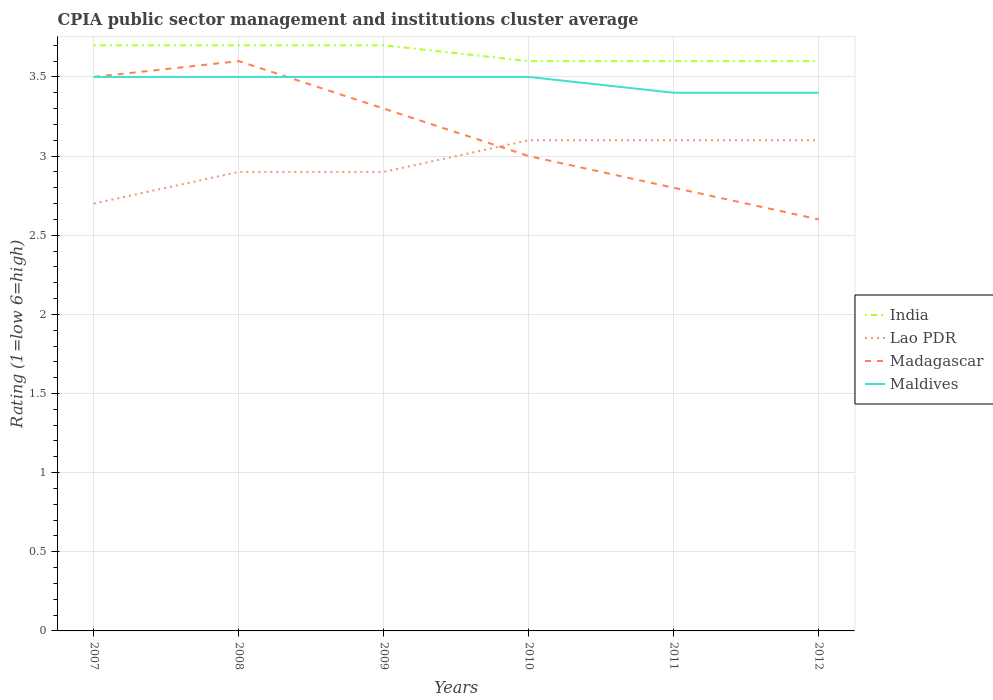Is the number of lines equal to the number of legend labels?
Provide a succinct answer. Yes. In which year was the CPIA rating in India maximum?
Keep it short and to the point. 2010. What is the total CPIA rating in Madagascar in the graph?
Your answer should be very brief. 0.2. What is the difference between the highest and the second highest CPIA rating in Lao PDR?
Give a very brief answer. 0.4. What is the difference between the highest and the lowest CPIA rating in Lao PDR?
Your answer should be very brief. 3. Is the CPIA rating in India strictly greater than the CPIA rating in Madagascar over the years?
Offer a terse response. No. How many years are there in the graph?
Keep it short and to the point. 6. What is the difference between two consecutive major ticks on the Y-axis?
Provide a short and direct response. 0.5. Does the graph contain any zero values?
Provide a succinct answer. No. What is the title of the graph?
Your response must be concise. CPIA public sector management and institutions cluster average. Does "Peru" appear as one of the legend labels in the graph?
Make the answer very short. No. What is the label or title of the Y-axis?
Provide a short and direct response. Rating (1=low 6=high). What is the Rating (1=low 6=high) in India in 2007?
Provide a short and direct response. 3.7. What is the Rating (1=low 6=high) in Lao PDR in 2008?
Give a very brief answer. 2.9. What is the Rating (1=low 6=high) in India in 2009?
Your answer should be compact. 3.7. What is the Rating (1=low 6=high) of Madagascar in 2009?
Keep it short and to the point. 3.3. What is the Rating (1=low 6=high) in Lao PDR in 2010?
Keep it short and to the point. 3.1. What is the Rating (1=low 6=high) in India in 2011?
Provide a succinct answer. 3.6. What is the Rating (1=low 6=high) in Lao PDR in 2011?
Your response must be concise. 3.1. What is the Rating (1=low 6=high) of Madagascar in 2011?
Provide a succinct answer. 2.8. What is the Rating (1=low 6=high) of Lao PDR in 2012?
Give a very brief answer. 3.1. What is the Rating (1=low 6=high) of Madagascar in 2012?
Ensure brevity in your answer.  2.6. What is the Rating (1=low 6=high) in Maldives in 2012?
Ensure brevity in your answer.  3.4. Across all years, what is the maximum Rating (1=low 6=high) in India?
Offer a terse response. 3.7. Across all years, what is the maximum Rating (1=low 6=high) in Lao PDR?
Your answer should be compact. 3.1. Across all years, what is the minimum Rating (1=low 6=high) of Lao PDR?
Give a very brief answer. 2.7. Across all years, what is the minimum Rating (1=low 6=high) in Madagascar?
Give a very brief answer. 2.6. What is the total Rating (1=low 6=high) in India in the graph?
Offer a very short reply. 21.9. What is the total Rating (1=low 6=high) in Lao PDR in the graph?
Ensure brevity in your answer.  17.8. What is the total Rating (1=low 6=high) of Madagascar in the graph?
Ensure brevity in your answer.  18.8. What is the total Rating (1=low 6=high) in Maldives in the graph?
Ensure brevity in your answer.  20.8. What is the difference between the Rating (1=low 6=high) in India in 2007 and that in 2008?
Your answer should be very brief. 0. What is the difference between the Rating (1=low 6=high) of Lao PDR in 2007 and that in 2008?
Provide a short and direct response. -0.2. What is the difference between the Rating (1=low 6=high) in Maldives in 2007 and that in 2008?
Provide a succinct answer. 0. What is the difference between the Rating (1=low 6=high) in India in 2007 and that in 2009?
Provide a short and direct response. 0. What is the difference between the Rating (1=low 6=high) in Madagascar in 2007 and that in 2009?
Offer a very short reply. 0.2. What is the difference between the Rating (1=low 6=high) of Maldives in 2007 and that in 2009?
Your answer should be very brief. 0. What is the difference between the Rating (1=low 6=high) in Madagascar in 2007 and that in 2010?
Offer a terse response. 0.5. What is the difference between the Rating (1=low 6=high) of Maldives in 2007 and that in 2010?
Keep it short and to the point. 0. What is the difference between the Rating (1=low 6=high) in India in 2007 and that in 2011?
Offer a terse response. 0.1. What is the difference between the Rating (1=low 6=high) of Lao PDR in 2007 and that in 2011?
Make the answer very short. -0.4. What is the difference between the Rating (1=low 6=high) of Madagascar in 2007 and that in 2011?
Keep it short and to the point. 0.7. What is the difference between the Rating (1=low 6=high) in India in 2007 and that in 2012?
Give a very brief answer. 0.1. What is the difference between the Rating (1=low 6=high) of Lao PDR in 2007 and that in 2012?
Your answer should be very brief. -0.4. What is the difference between the Rating (1=low 6=high) in Madagascar in 2007 and that in 2012?
Offer a very short reply. 0.9. What is the difference between the Rating (1=low 6=high) in Maldives in 2008 and that in 2009?
Provide a short and direct response. 0. What is the difference between the Rating (1=low 6=high) of India in 2008 and that in 2010?
Give a very brief answer. 0.1. What is the difference between the Rating (1=low 6=high) in Lao PDR in 2008 and that in 2010?
Ensure brevity in your answer.  -0.2. What is the difference between the Rating (1=low 6=high) of Madagascar in 2008 and that in 2011?
Offer a terse response. 0.8. What is the difference between the Rating (1=low 6=high) in Lao PDR in 2008 and that in 2012?
Make the answer very short. -0.2. What is the difference between the Rating (1=low 6=high) of Madagascar in 2008 and that in 2012?
Ensure brevity in your answer.  1. What is the difference between the Rating (1=low 6=high) of Maldives in 2008 and that in 2012?
Your response must be concise. 0.1. What is the difference between the Rating (1=low 6=high) of Lao PDR in 2009 and that in 2010?
Ensure brevity in your answer.  -0.2. What is the difference between the Rating (1=low 6=high) in Madagascar in 2009 and that in 2011?
Keep it short and to the point. 0.5. What is the difference between the Rating (1=low 6=high) of Maldives in 2009 and that in 2011?
Provide a short and direct response. 0.1. What is the difference between the Rating (1=low 6=high) in India in 2009 and that in 2012?
Ensure brevity in your answer.  0.1. What is the difference between the Rating (1=low 6=high) of Lao PDR in 2009 and that in 2012?
Make the answer very short. -0.2. What is the difference between the Rating (1=low 6=high) in Madagascar in 2009 and that in 2012?
Your answer should be compact. 0.7. What is the difference between the Rating (1=low 6=high) of India in 2010 and that in 2011?
Offer a terse response. 0. What is the difference between the Rating (1=low 6=high) of Lao PDR in 2010 and that in 2011?
Provide a short and direct response. 0. What is the difference between the Rating (1=low 6=high) in Madagascar in 2010 and that in 2011?
Offer a very short reply. 0.2. What is the difference between the Rating (1=low 6=high) of India in 2010 and that in 2012?
Provide a short and direct response. 0. What is the difference between the Rating (1=low 6=high) in Maldives in 2011 and that in 2012?
Provide a succinct answer. 0. What is the difference between the Rating (1=low 6=high) in India in 2007 and the Rating (1=low 6=high) in Lao PDR in 2008?
Make the answer very short. 0.8. What is the difference between the Rating (1=low 6=high) of Lao PDR in 2007 and the Rating (1=low 6=high) of Madagascar in 2008?
Offer a terse response. -0.9. What is the difference between the Rating (1=low 6=high) of Lao PDR in 2007 and the Rating (1=low 6=high) of Maldives in 2008?
Offer a very short reply. -0.8. What is the difference between the Rating (1=low 6=high) of India in 2007 and the Rating (1=low 6=high) of Lao PDR in 2009?
Give a very brief answer. 0.8. What is the difference between the Rating (1=low 6=high) in India in 2007 and the Rating (1=low 6=high) in Madagascar in 2009?
Offer a very short reply. 0.4. What is the difference between the Rating (1=low 6=high) in India in 2007 and the Rating (1=low 6=high) in Maldives in 2009?
Provide a short and direct response. 0.2. What is the difference between the Rating (1=low 6=high) of Lao PDR in 2007 and the Rating (1=low 6=high) of Madagascar in 2009?
Your answer should be compact. -0.6. What is the difference between the Rating (1=low 6=high) in Lao PDR in 2007 and the Rating (1=low 6=high) in Maldives in 2009?
Offer a very short reply. -0.8. What is the difference between the Rating (1=low 6=high) of India in 2007 and the Rating (1=low 6=high) of Madagascar in 2010?
Keep it short and to the point. 0.7. What is the difference between the Rating (1=low 6=high) of Lao PDR in 2007 and the Rating (1=low 6=high) of Madagascar in 2010?
Keep it short and to the point. -0.3. What is the difference between the Rating (1=low 6=high) in India in 2007 and the Rating (1=low 6=high) in Lao PDR in 2011?
Give a very brief answer. 0.6. What is the difference between the Rating (1=low 6=high) of India in 2007 and the Rating (1=low 6=high) of Madagascar in 2011?
Offer a very short reply. 0.9. What is the difference between the Rating (1=low 6=high) of Madagascar in 2007 and the Rating (1=low 6=high) of Maldives in 2011?
Your response must be concise. 0.1. What is the difference between the Rating (1=low 6=high) in Lao PDR in 2007 and the Rating (1=low 6=high) in Maldives in 2012?
Keep it short and to the point. -0.7. What is the difference between the Rating (1=low 6=high) of India in 2008 and the Rating (1=low 6=high) of Lao PDR in 2009?
Ensure brevity in your answer.  0.8. What is the difference between the Rating (1=low 6=high) in India in 2008 and the Rating (1=low 6=high) in Maldives in 2009?
Your response must be concise. 0.2. What is the difference between the Rating (1=low 6=high) in Lao PDR in 2008 and the Rating (1=low 6=high) in Madagascar in 2009?
Keep it short and to the point. -0.4. What is the difference between the Rating (1=low 6=high) of Lao PDR in 2008 and the Rating (1=low 6=high) of Maldives in 2009?
Your response must be concise. -0.6. What is the difference between the Rating (1=low 6=high) of India in 2008 and the Rating (1=low 6=high) of Lao PDR in 2010?
Your response must be concise. 0.6. What is the difference between the Rating (1=low 6=high) in India in 2008 and the Rating (1=low 6=high) in Lao PDR in 2011?
Your response must be concise. 0.6. What is the difference between the Rating (1=low 6=high) in India in 2008 and the Rating (1=low 6=high) in Madagascar in 2011?
Keep it short and to the point. 0.9. What is the difference between the Rating (1=low 6=high) of Lao PDR in 2008 and the Rating (1=low 6=high) of Maldives in 2011?
Make the answer very short. -0.5. What is the difference between the Rating (1=low 6=high) in India in 2008 and the Rating (1=low 6=high) in Maldives in 2012?
Make the answer very short. 0.3. What is the difference between the Rating (1=low 6=high) in Lao PDR in 2008 and the Rating (1=low 6=high) in Madagascar in 2012?
Make the answer very short. 0.3. What is the difference between the Rating (1=low 6=high) of Madagascar in 2008 and the Rating (1=low 6=high) of Maldives in 2012?
Ensure brevity in your answer.  0.2. What is the difference between the Rating (1=low 6=high) in India in 2009 and the Rating (1=low 6=high) in Madagascar in 2010?
Give a very brief answer. 0.7. What is the difference between the Rating (1=low 6=high) in India in 2009 and the Rating (1=low 6=high) in Maldives in 2010?
Keep it short and to the point. 0.2. What is the difference between the Rating (1=low 6=high) of Lao PDR in 2009 and the Rating (1=low 6=high) of Madagascar in 2010?
Your response must be concise. -0.1. What is the difference between the Rating (1=low 6=high) in Lao PDR in 2009 and the Rating (1=low 6=high) in Maldives in 2010?
Give a very brief answer. -0.6. What is the difference between the Rating (1=low 6=high) of India in 2009 and the Rating (1=low 6=high) of Maldives in 2011?
Offer a terse response. 0.3. What is the difference between the Rating (1=low 6=high) in Lao PDR in 2009 and the Rating (1=low 6=high) in Madagascar in 2011?
Your answer should be very brief. 0.1. What is the difference between the Rating (1=low 6=high) in Madagascar in 2009 and the Rating (1=low 6=high) in Maldives in 2011?
Provide a succinct answer. -0.1. What is the difference between the Rating (1=low 6=high) in India in 2009 and the Rating (1=low 6=high) in Lao PDR in 2012?
Ensure brevity in your answer.  0.6. What is the difference between the Rating (1=low 6=high) in Lao PDR in 2009 and the Rating (1=low 6=high) in Maldives in 2012?
Offer a terse response. -0.5. What is the difference between the Rating (1=low 6=high) of Madagascar in 2009 and the Rating (1=low 6=high) of Maldives in 2012?
Provide a short and direct response. -0.1. What is the difference between the Rating (1=low 6=high) in India in 2010 and the Rating (1=low 6=high) in Lao PDR in 2011?
Make the answer very short. 0.5. What is the difference between the Rating (1=low 6=high) in India in 2010 and the Rating (1=low 6=high) in Madagascar in 2011?
Keep it short and to the point. 0.8. What is the difference between the Rating (1=low 6=high) in India in 2010 and the Rating (1=low 6=high) in Maldives in 2011?
Provide a succinct answer. 0.2. What is the difference between the Rating (1=low 6=high) of Lao PDR in 2010 and the Rating (1=low 6=high) of Maldives in 2011?
Keep it short and to the point. -0.3. What is the difference between the Rating (1=low 6=high) of India in 2010 and the Rating (1=low 6=high) of Madagascar in 2012?
Offer a terse response. 1. What is the difference between the Rating (1=low 6=high) in India in 2010 and the Rating (1=low 6=high) in Maldives in 2012?
Make the answer very short. 0.2. What is the difference between the Rating (1=low 6=high) in Lao PDR in 2010 and the Rating (1=low 6=high) in Madagascar in 2012?
Your answer should be very brief. 0.5. What is the difference between the Rating (1=low 6=high) in Madagascar in 2010 and the Rating (1=low 6=high) in Maldives in 2012?
Your answer should be very brief. -0.4. What is the difference between the Rating (1=low 6=high) in India in 2011 and the Rating (1=low 6=high) in Lao PDR in 2012?
Offer a terse response. 0.5. What is the difference between the Rating (1=low 6=high) in India in 2011 and the Rating (1=low 6=high) in Maldives in 2012?
Provide a succinct answer. 0.2. What is the difference between the Rating (1=low 6=high) of Lao PDR in 2011 and the Rating (1=low 6=high) of Madagascar in 2012?
Provide a short and direct response. 0.5. What is the difference between the Rating (1=low 6=high) in Lao PDR in 2011 and the Rating (1=low 6=high) in Maldives in 2012?
Offer a terse response. -0.3. What is the difference between the Rating (1=low 6=high) of Madagascar in 2011 and the Rating (1=low 6=high) of Maldives in 2012?
Your answer should be compact. -0.6. What is the average Rating (1=low 6=high) in India per year?
Your answer should be very brief. 3.65. What is the average Rating (1=low 6=high) of Lao PDR per year?
Your answer should be compact. 2.97. What is the average Rating (1=low 6=high) of Madagascar per year?
Make the answer very short. 3.13. What is the average Rating (1=low 6=high) in Maldives per year?
Provide a short and direct response. 3.47. In the year 2007, what is the difference between the Rating (1=low 6=high) of India and Rating (1=low 6=high) of Lao PDR?
Your response must be concise. 1. In the year 2007, what is the difference between the Rating (1=low 6=high) in Lao PDR and Rating (1=low 6=high) in Madagascar?
Keep it short and to the point. -0.8. In the year 2007, what is the difference between the Rating (1=low 6=high) in Lao PDR and Rating (1=low 6=high) in Maldives?
Provide a short and direct response. -0.8. In the year 2008, what is the difference between the Rating (1=low 6=high) in India and Rating (1=low 6=high) in Maldives?
Offer a terse response. 0.2. In the year 2008, what is the difference between the Rating (1=low 6=high) of Lao PDR and Rating (1=low 6=high) of Madagascar?
Give a very brief answer. -0.7. In the year 2008, what is the difference between the Rating (1=low 6=high) of Lao PDR and Rating (1=low 6=high) of Maldives?
Give a very brief answer. -0.6. In the year 2008, what is the difference between the Rating (1=low 6=high) in Madagascar and Rating (1=low 6=high) in Maldives?
Your answer should be compact. 0.1. In the year 2009, what is the difference between the Rating (1=low 6=high) in India and Rating (1=low 6=high) in Lao PDR?
Provide a short and direct response. 0.8. In the year 2009, what is the difference between the Rating (1=low 6=high) in India and Rating (1=low 6=high) in Madagascar?
Offer a terse response. 0.4. In the year 2009, what is the difference between the Rating (1=low 6=high) in India and Rating (1=low 6=high) in Maldives?
Provide a short and direct response. 0.2. In the year 2009, what is the difference between the Rating (1=low 6=high) in Lao PDR and Rating (1=low 6=high) in Madagascar?
Provide a succinct answer. -0.4. In the year 2010, what is the difference between the Rating (1=low 6=high) of India and Rating (1=low 6=high) of Maldives?
Your answer should be compact. 0.1. In the year 2010, what is the difference between the Rating (1=low 6=high) of Lao PDR and Rating (1=low 6=high) of Maldives?
Provide a short and direct response. -0.4. In the year 2011, what is the difference between the Rating (1=low 6=high) of India and Rating (1=low 6=high) of Lao PDR?
Provide a short and direct response. 0.5. In the year 2011, what is the difference between the Rating (1=low 6=high) in Lao PDR and Rating (1=low 6=high) in Maldives?
Your answer should be very brief. -0.3. In the year 2011, what is the difference between the Rating (1=low 6=high) in Madagascar and Rating (1=low 6=high) in Maldives?
Give a very brief answer. -0.6. In the year 2012, what is the difference between the Rating (1=low 6=high) in India and Rating (1=low 6=high) in Lao PDR?
Make the answer very short. 0.5. In the year 2012, what is the difference between the Rating (1=low 6=high) of Lao PDR and Rating (1=low 6=high) of Madagascar?
Your response must be concise. 0.5. In the year 2012, what is the difference between the Rating (1=low 6=high) of Madagascar and Rating (1=low 6=high) of Maldives?
Your answer should be very brief. -0.8. What is the ratio of the Rating (1=low 6=high) of Madagascar in 2007 to that in 2008?
Offer a very short reply. 0.97. What is the ratio of the Rating (1=low 6=high) in Maldives in 2007 to that in 2008?
Your answer should be compact. 1. What is the ratio of the Rating (1=low 6=high) in Lao PDR in 2007 to that in 2009?
Your answer should be compact. 0.93. What is the ratio of the Rating (1=low 6=high) of Madagascar in 2007 to that in 2009?
Provide a short and direct response. 1.06. What is the ratio of the Rating (1=low 6=high) in India in 2007 to that in 2010?
Make the answer very short. 1.03. What is the ratio of the Rating (1=low 6=high) of Lao PDR in 2007 to that in 2010?
Ensure brevity in your answer.  0.87. What is the ratio of the Rating (1=low 6=high) in India in 2007 to that in 2011?
Offer a very short reply. 1.03. What is the ratio of the Rating (1=low 6=high) in Lao PDR in 2007 to that in 2011?
Make the answer very short. 0.87. What is the ratio of the Rating (1=low 6=high) of Madagascar in 2007 to that in 2011?
Offer a terse response. 1.25. What is the ratio of the Rating (1=low 6=high) in Maldives in 2007 to that in 2011?
Offer a very short reply. 1.03. What is the ratio of the Rating (1=low 6=high) in India in 2007 to that in 2012?
Provide a short and direct response. 1.03. What is the ratio of the Rating (1=low 6=high) in Lao PDR in 2007 to that in 2012?
Make the answer very short. 0.87. What is the ratio of the Rating (1=low 6=high) in Madagascar in 2007 to that in 2012?
Ensure brevity in your answer.  1.35. What is the ratio of the Rating (1=low 6=high) of Maldives in 2007 to that in 2012?
Provide a succinct answer. 1.03. What is the ratio of the Rating (1=low 6=high) of Madagascar in 2008 to that in 2009?
Ensure brevity in your answer.  1.09. What is the ratio of the Rating (1=low 6=high) of India in 2008 to that in 2010?
Offer a very short reply. 1.03. What is the ratio of the Rating (1=low 6=high) of Lao PDR in 2008 to that in 2010?
Ensure brevity in your answer.  0.94. What is the ratio of the Rating (1=low 6=high) in Madagascar in 2008 to that in 2010?
Offer a terse response. 1.2. What is the ratio of the Rating (1=low 6=high) of India in 2008 to that in 2011?
Ensure brevity in your answer.  1.03. What is the ratio of the Rating (1=low 6=high) in Lao PDR in 2008 to that in 2011?
Your answer should be very brief. 0.94. What is the ratio of the Rating (1=low 6=high) in Madagascar in 2008 to that in 2011?
Give a very brief answer. 1.29. What is the ratio of the Rating (1=low 6=high) in Maldives in 2008 to that in 2011?
Provide a succinct answer. 1.03. What is the ratio of the Rating (1=low 6=high) of India in 2008 to that in 2012?
Provide a short and direct response. 1.03. What is the ratio of the Rating (1=low 6=high) of Lao PDR in 2008 to that in 2012?
Your answer should be compact. 0.94. What is the ratio of the Rating (1=low 6=high) of Madagascar in 2008 to that in 2012?
Your answer should be very brief. 1.38. What is the ratio of the Rating (1=low 6=high) in Maldives in 2008 to that in 2012?
Make the answer very short. 1.03. What is the ratio of the Rating (1=low 6=high) in India in 2009 to that in 2010?
Your answer should be compact. 1.03. What is the ratio of the Rating (1=low 6=high) in Lao PDR in 2009 to that in 2010?
Provide a succinct answer. 0.94. What is the ratio of the Rating (1=low 6=high) of Madagascar in 2009 to that in 2010?
Your answer should be compact. 1.1. What is the ratio of the Rating (1=low 6=high) in Maldives in 2009 to that in 2010?
Provide a short and direct response. 1. What is the ratio of the Rating (1=low 6=high) of India in 2009 to that in 2011?
Your answer should be very brief. 1.03. What is the ratio of the Rating (1=low 6=high) in Lao PDR in 2009 to that in 2011?
Your answer should be very brief. 0.94. What is the ratio of the Rating (1=low 6=high) in Madagascar in 2009 to that in 2011?
Offer a terse response. 1.18. What is the ratio of the Rating (1=low 6=high) in Maldives in 2009 to that in 2011?
Make the answer very short. 1.03. What is the ratio of the Rating (1=low 6=high) of India in 2009 to that in 2012?
Give a very brief answer. 1.03. What is the ratio of the Rating (1=low 6=high) in Lao PDR in 2009 to that in 2012?
Provide a succinct answer. 0.94. What is the ratio of the Rating (1=low 6=high) of Madagascar in 2009 to that in 2012?
Offer a very short reply. 1.27. What is the ratio of the Rating (1=low 6=high) of Maldives in 2009 to that in 2012?
Keep it short and to the point. 1.03. What is the ratio of the Rating (1=low 6=high) of India in 2010 to that in 2011?
Provide a short and direct response. 1. What is the ratio of the Rating (1=low 6=high) of Lao PDR in 2010 to that in 2011?
Make the answer very short. 1. What is the ratio of the Rating (1=low 6=high) of Madagascar in 2010 to that in 2011?
Make the answer very short. 1.07. What is the ratio of the Rating (1=low 6=high) of Maldives in 2010 to that in 2011?
Your answer should be very brief. 1.03. What is the ratio of the Rating (1=low 6=high) in Lao PDR in 2010 to that in 2012?
Offer a terse response. 1. What is the ratio of the Rating (1=low 6=high) of Madagascar in 2010 to that in 2012?
Make the answer very short. 1.15. What is the ratio of the Rating (1=low 6=high) of Maldives in 2010 to that in 2012?
Provide a short and direct response. 1.03. What is the ratio of the Rating (1=low 6=high) of Lao PDR in 2011 to that in 2012?
Provide a short and direct response. 1. What is the difference between the highest and the second highest Rating (1=low 6=high) of Lao PDR?
Ensure brevity in your answer.  0. What is the difference between the highest and the lowest Rating (1=low 6=high) in Madagascar?
Make the answer very short. 1. What is the difference between the highest and the lowest Rating (1=low 6=high) of Maldives?
Your answer should be very brief. 0.1. 